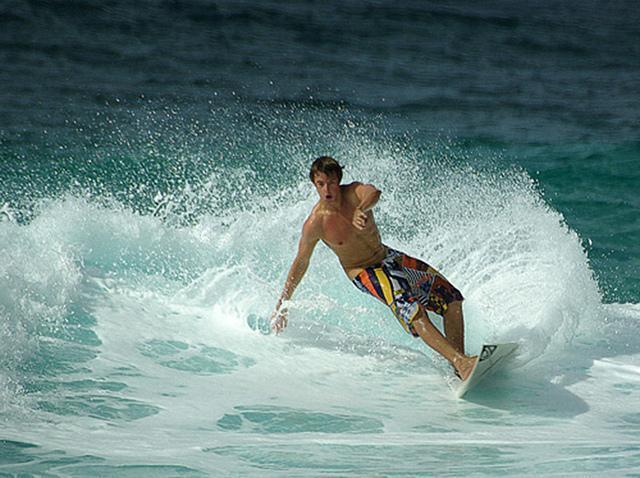How many panel partitions on the blue umbrella have writing on them?
Give a very brief answer. 0. 